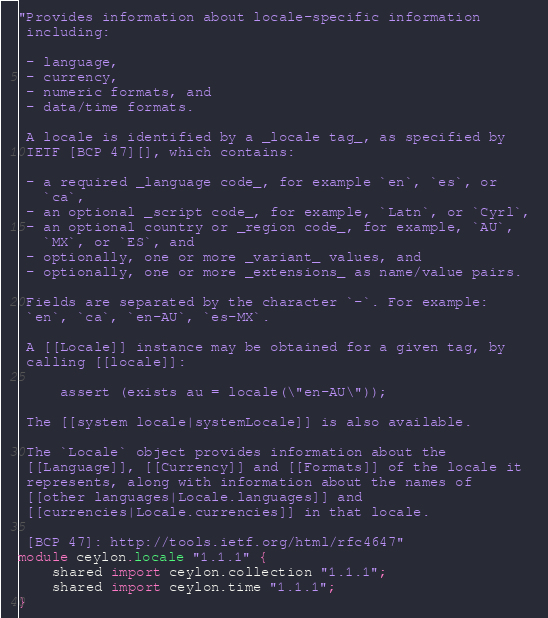<code> <loc_0><loc_0><loc_500><loc_500><_Ceylon_>"Provides information about locale-specific information
 including:
 
 - language,
 - currency,
 - numeric formats, and
 - data/time formats.
 
 A locale is identified by a _locale tag_, as specified by
 IETF [BCP 47][], which contains:
 
 - a required _language code_, for example `en`, `es`, or 
   `ca`,
 - an optional _script code_, for example, `Latn`, or `Cyrl`, 
 - an optional country or _region code_, for example, `AU`, 
   `MX`, or `ES`, and
 - optionally, one or more _variant_ values, and
 - optionally, one or more _extensions_ as name/value pairs.
 
 Fields are separated by the character `-`. For example:
 `en`, `ca`, `en-AU`, `es-MX`.
 
 A [[Locale]] instance may be obtained for a given tag, by
 calling [[locale]]:
 
     assert (exists au = locale(\"en-AU\"));
 
 The [[system locale|systemLocale]] is also available.
 
 The `Locale` object provides information about the 
 [[Language]], [[Currency]] and [[Formats]] of the locale it 
 represents, along with information about the names of 
 [[other languages|Locale.languages]] and 
 [[currencies|Locale.currencies]] in that locale.
 
 [BCP 47]: http://tools.ietf.org/html/rfc4647"
module ceylon.locale "1.1.1" {
    shared import ceylon.collection "1.1.1";
    shared import ceylon.time "1.1.1";
}
</code> 